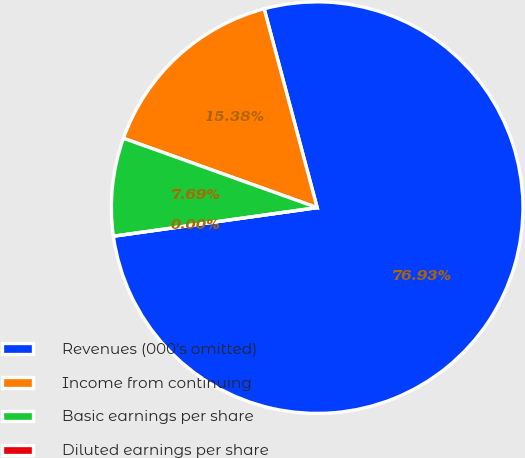<chart> <loc_0><loc_0><loc_500><loc_500><pie_chart><fcel>Revenues (000's omitted)<fcel>Income from continuing<fcel>Basic earnings per share<fcel>Diluted earnings per share<nl><fcel>76.92%<fcel>15.38%<fcel>7.69%<fcel>0.0%<nl></chart> 